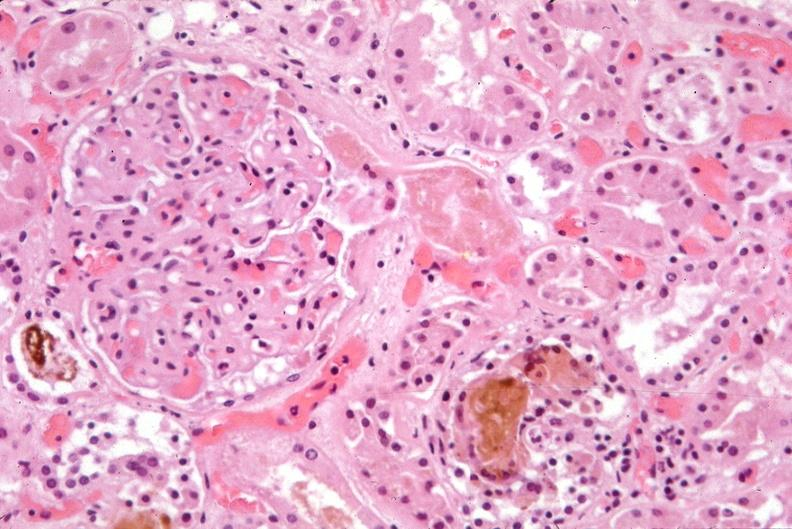where is this?
Answer the question using a single word or phrase. Urinary 